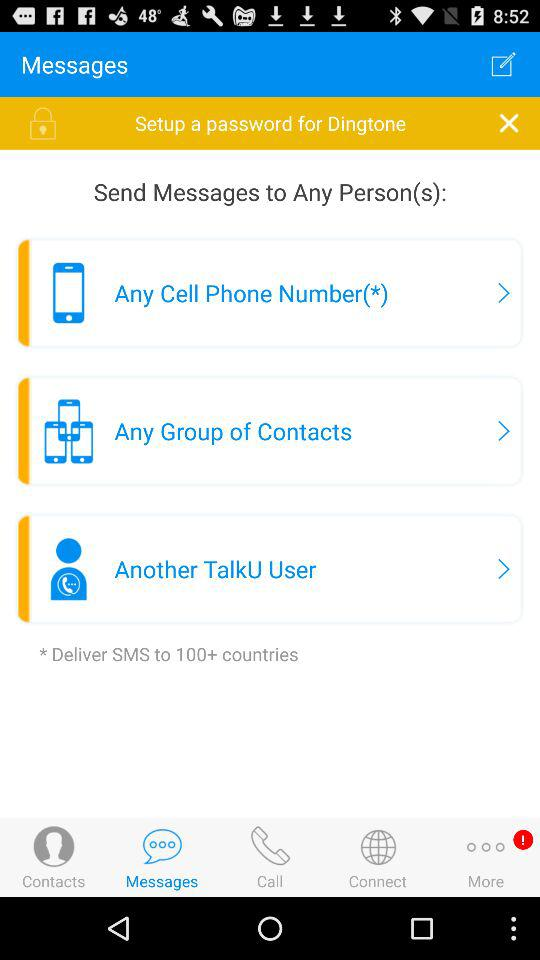How many notifications are there?
When the provided information is insufficient, respond with <no answer>. <no answer> 